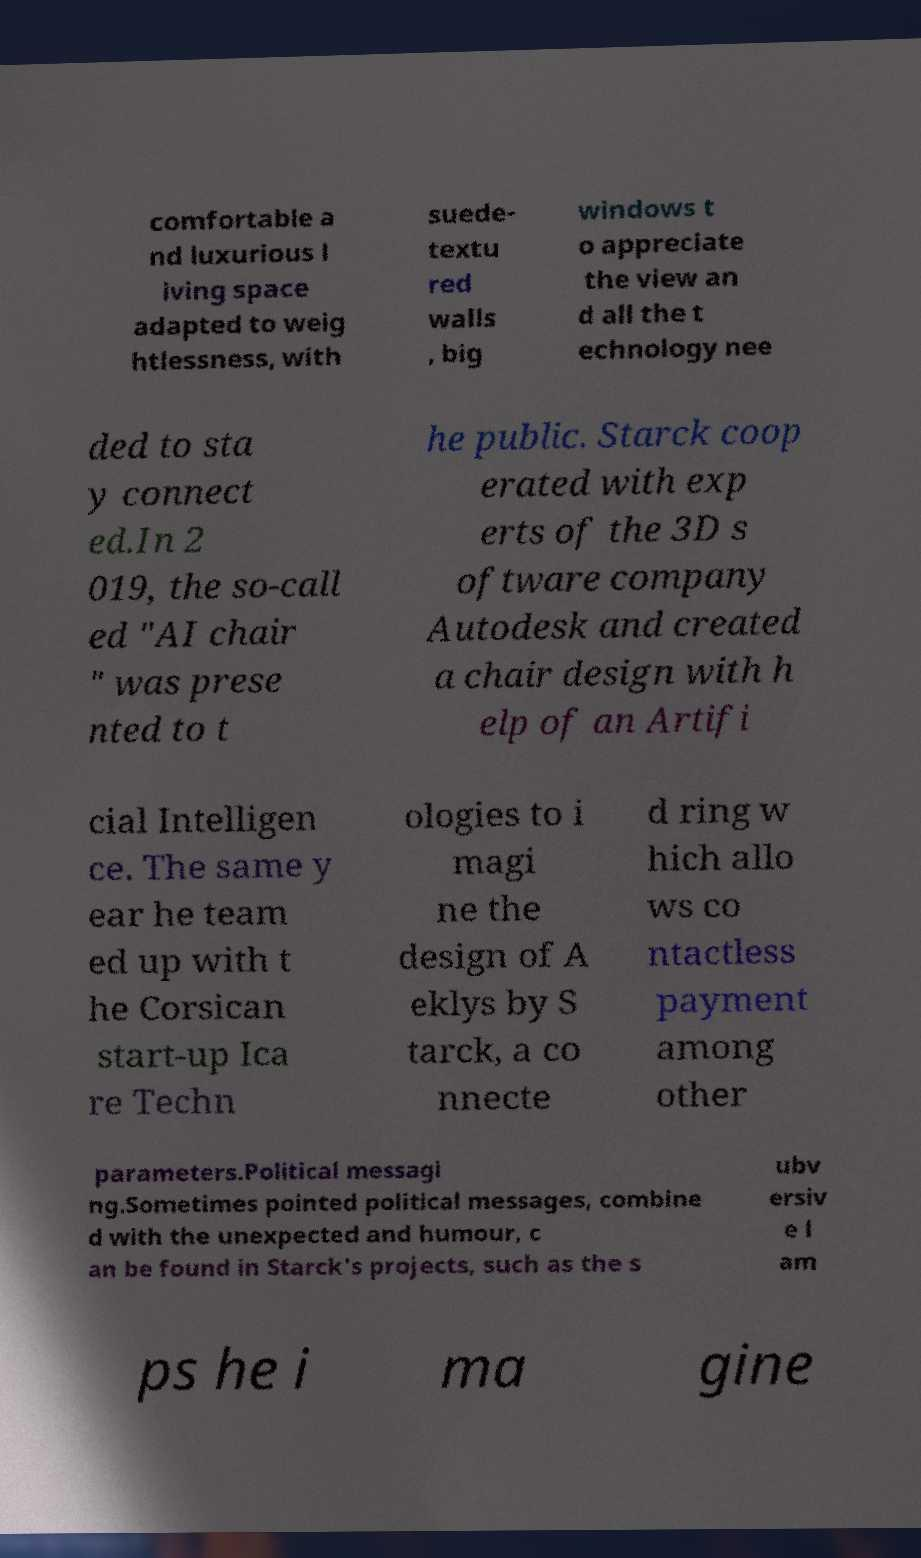Can you accurately transcribe the text from the provided image for me? comfortable a nd luxurious l iving space adapted to weig htlessness, with suede- textu red walls , big windows t o appreciate the view an d all the t echnology nee ded to sta y connect ed.In 2 019, the so-call ed "AI chair " was prese nted to t he public. Starck coop erated with exp erts of the 3D s oftware company Autodesk and created a chair design with h elp of an Artifi cial Intelligen ce. The same y ear he team ed up with t he Corsican start-up Ica re Techn ologies to i magi ne the design of A eklys by S tarck, a co nnecte d ring w hich allo ws co ntactless payment among other parameters.Political messagi ng.Sometimes pointed political messages, combine d with the unexpected and humour, c an be found in Starck's projects, such as the s ubv ersiv e l am ps he i ma gine 